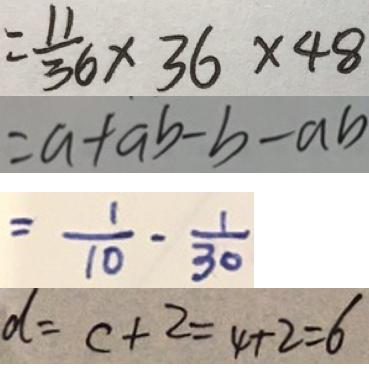Convert formula to latex. <formula><loc_0><loc_0><loc_500><loc_500>= \frac { 1 1 } { 3 6 } \times 3 6 \times 4 8 
 = a + a b - b - a b 
 = \frac { 1 } { 1 0 } - \frac { 1 } { 3 0 } 
 d = c + 2 = 4 + 2 = 6</formula> 